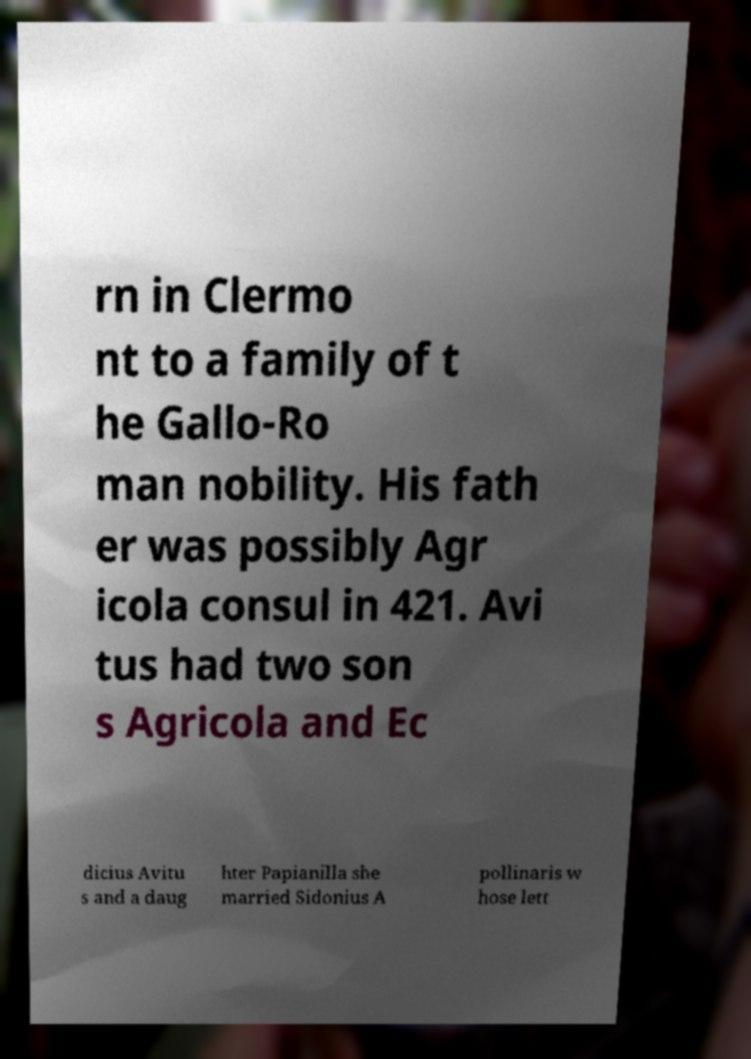Can you read and provide the text displayed in the image?This photo seems to have some interesting text. Can you extract and type it out for me? rn in Clermo nt to a family of t he Gallo-Ro man nobility. His fath er was possibly Agr icola consul in 421. Avi tus had two son s Agricola and Ec dicius Avitu s and a daug hter Papianilla she married Sidonius A pollinaris w hose lett 